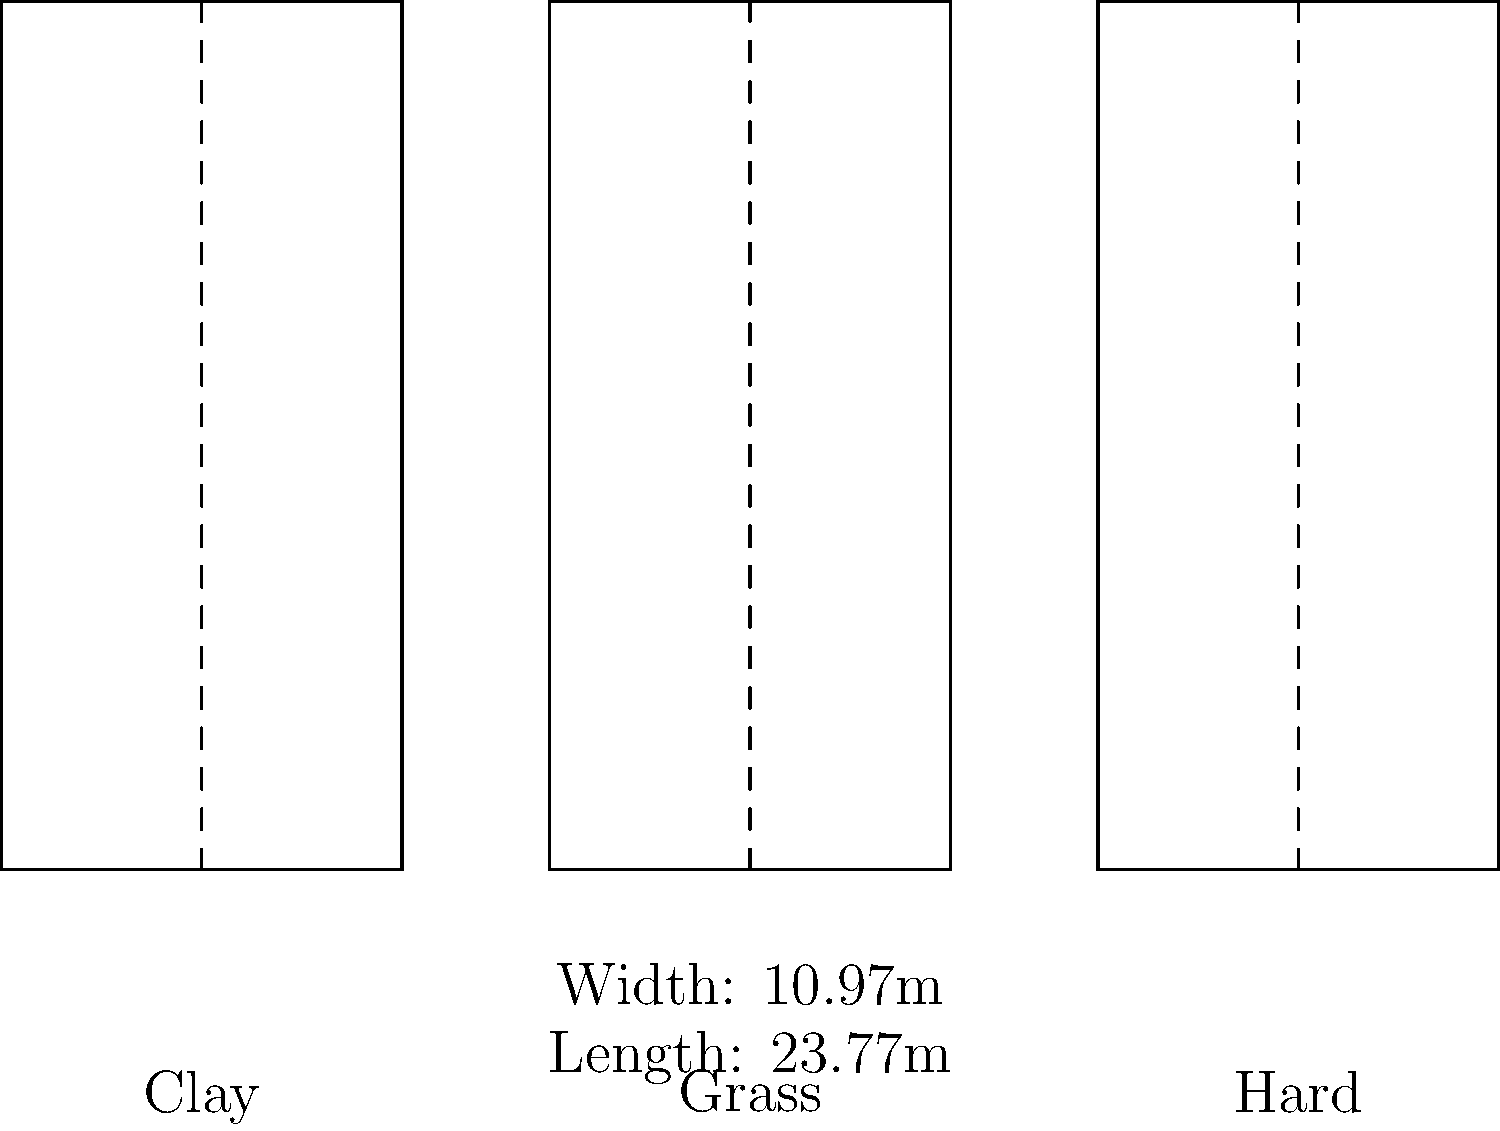Based on your experience with Coach Al Slawson and the court dimensions shown in the diagram, which statement is true about the official tennis court sizes for different surfaces? To answer this question, let's analyze the information provided in the diagram and recall our training experience:

1. The diagram shows three tennis courts: Clay, Grass, and Hard.
2. All three courts have the same dimensions:
   - Width: 10.97 meters
   - Length: 23.77 meters
3. This uniformity across surfaces is consistent with official tennis regulations.
4. The International Tennis Federation (ITF) standardizes court dimensions for all surfaces.
5. Coach Al Slawson would have emphasized the importance of adapting to different surfaces while maintaining consistent court dimensions.
6. The consistent dimensions ensure fair play across all professional tournaments, regardless of the surface.
7. While the playing characteristics (speed, bounce) may vary between surfaces, the court size remains constant.

Therefore, based on the diagram and our training knowledge, we can conclude that the official tennis court dimensions are the same for all surfaces: clay, grass, and hard courts.
Answer: The official tennis court dimensions are identical for all surfaces. 